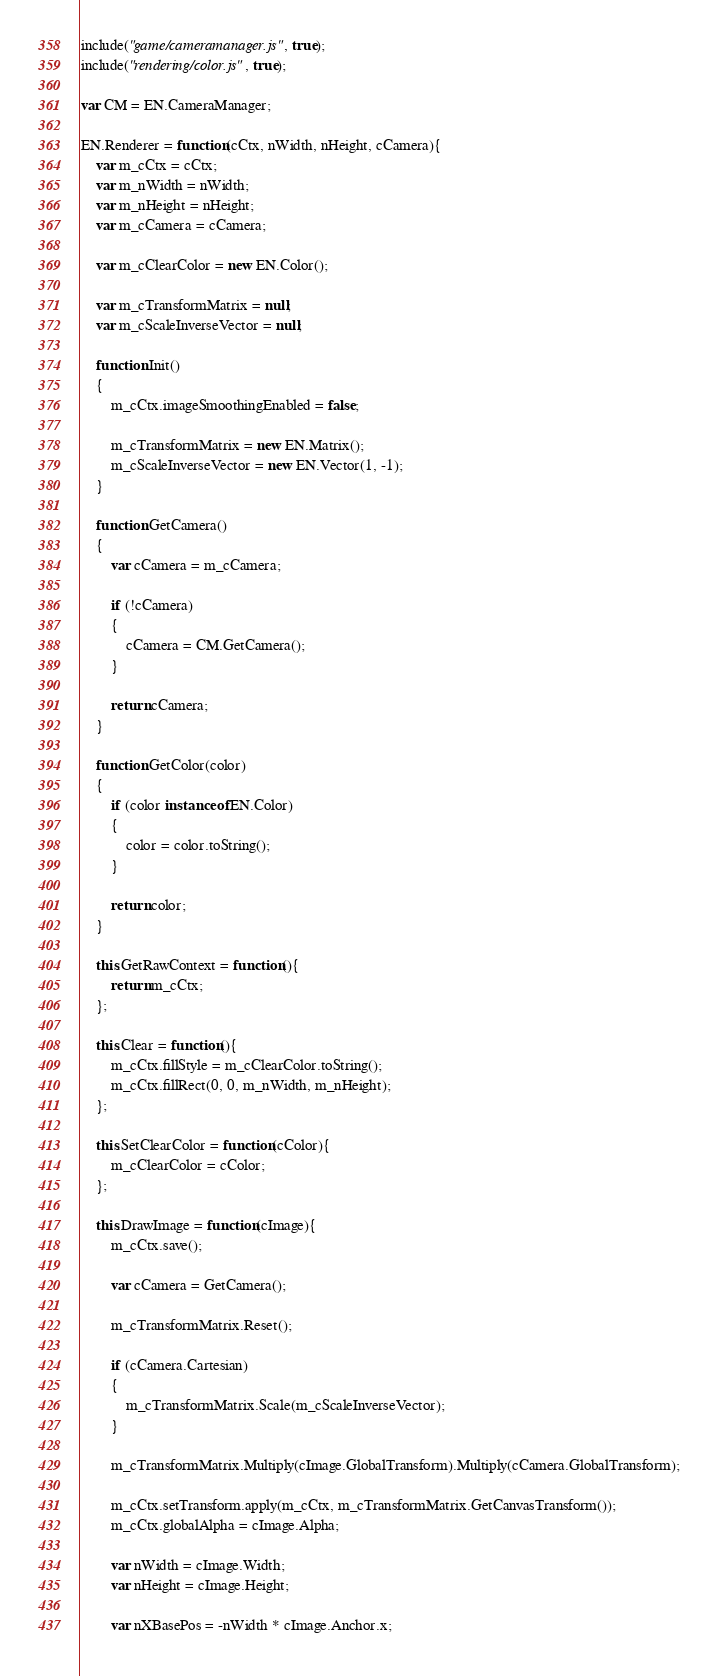Convert code to text. <code><loc_0><loc_0><loc_500><loc_500><_JavaScript_>include("game/cameramanager.js", true);
include("rendering/color.js", true);

var CM = EN.CameraManager;

EN.Renderer = function(cCtx, nWidth, nHeight, cCamera){
    var m_cCtx = cCtx;
    var m_nWidth = nWidth;
    var m_nHeight = nHeight;
    var m_cCamera = cCamera;
    
    var m_cClearColor = new EN.Color();
    
    var m_cTransformMatrix = null;
    var m_cScaleInverseVector = null;
    
    function Init()
    {
        m_cCtx.imageSmoothingEnabled = false;
        
        m_cTransformMatrix = new EN.Matrix();
        m_cScaleInverseVector = new EN.Vector(1, -1);
    }

    function GetCamera()
    {
        var cCamera = m_cCamera;

        if (!cCamera)
        {
            cCamera = CM.GetCamera();
        }

        return cCamera;
    }
    
    function GetColor(color)
    {
        if (color instanceof EN.Color)
        {
            color = color.toString();
        }
        
        return color;
    }
    
    this.GetRawContext = function(){
        return m_cCtx;
    };
    
    this.Clear = function(){
        m_cCtx.fillStyle = m_cClearColor.toString();
        m_cCtx.fillRect(0, 0, m_nWidth, m_nHeight);
    };
    
    this.SetClearColor = function(cColor){
        m_cClearColor = cColor;
    };
    
    this.DrawImage = function(cImage){
        m_cCtx.save();
        
        var cCamera = GetCamera();
        
        m_cTransformMatrix.Reset();
        
        if (cCamera.Cartesian)
        {
            m_cTransformMatrix.Scale(m_cScaleInverseVector);
        }
        
        m_cTransformMatrix.Multiply(cImage.GlobalTransform).Multiply(cCamera.GlobalTransform);
        
        m_cCtx.setTransform.apply(m_cCtx, m_cTransformMatrix.GetCanvasTransform());
        m_cCtx.globalAlpha = cImage.Alpha;

        var nWidth = cImage.Width;
        var nHeight = cImage.Height;

        var nXBasePos = -nWidth * cImage.Anchor.x;</code> 